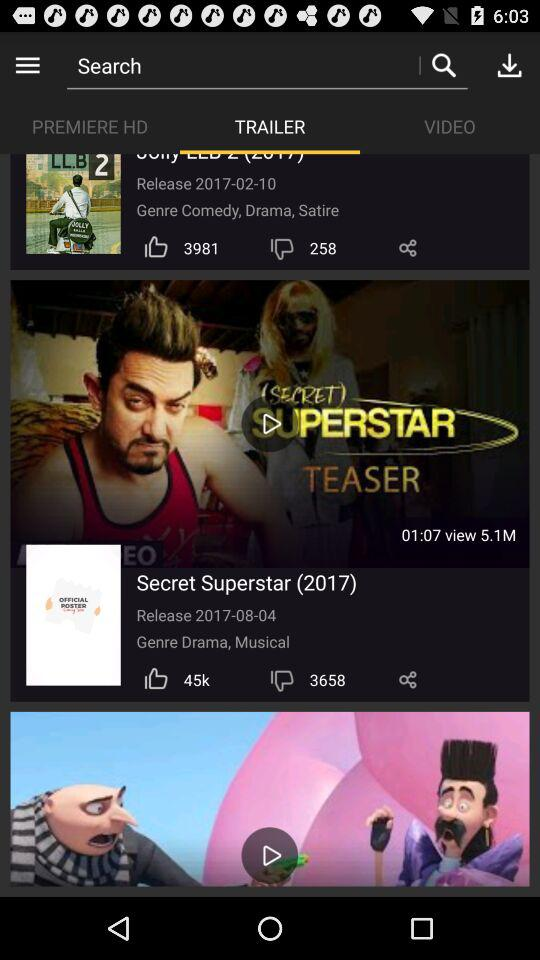How many likes did Secret Superstar (2017) get? There are 45k likes. 